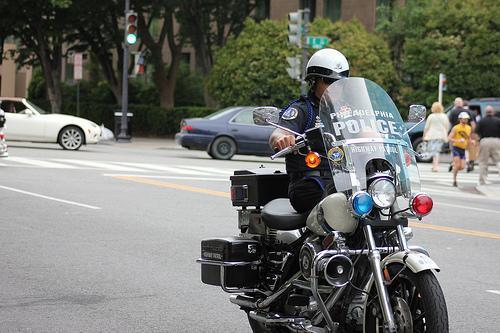How many officers are there?
Give a very brief answer. 1. How many policemen are in a car_?
Give a very brief answer. 0. How many people are a police officer?
Give a very brief answer. 1. 